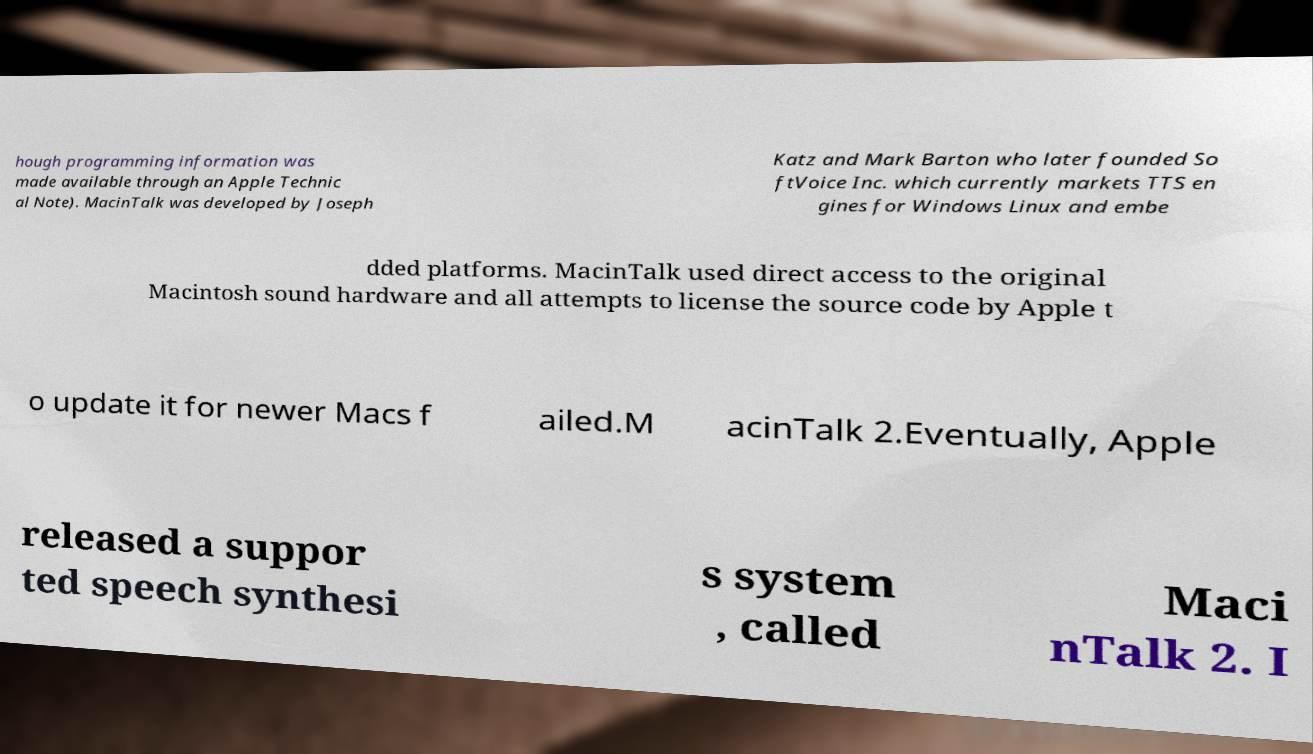Could you extract and type out the text from this image? hough programming information was made available through an Apple Technic al Note). MacinTalk was developed by Joseph Katz and Mark Barton who later founded So ftVoice Inc. which currently markets TTS en gines for Windows Linux and embe dded platforms. MacinTalk used direct access to the original Macintosh sound hardware and all attempts to license the source code by Apple t o update it for newer Macs f ailed.M acinTalk 2.Eventually, Apple released a suppor ted speech synthesi s system , called Maci nTalk 2. I 